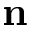<formula> <loc_0><loc_0><loc_500><loc_500>n</formula> 